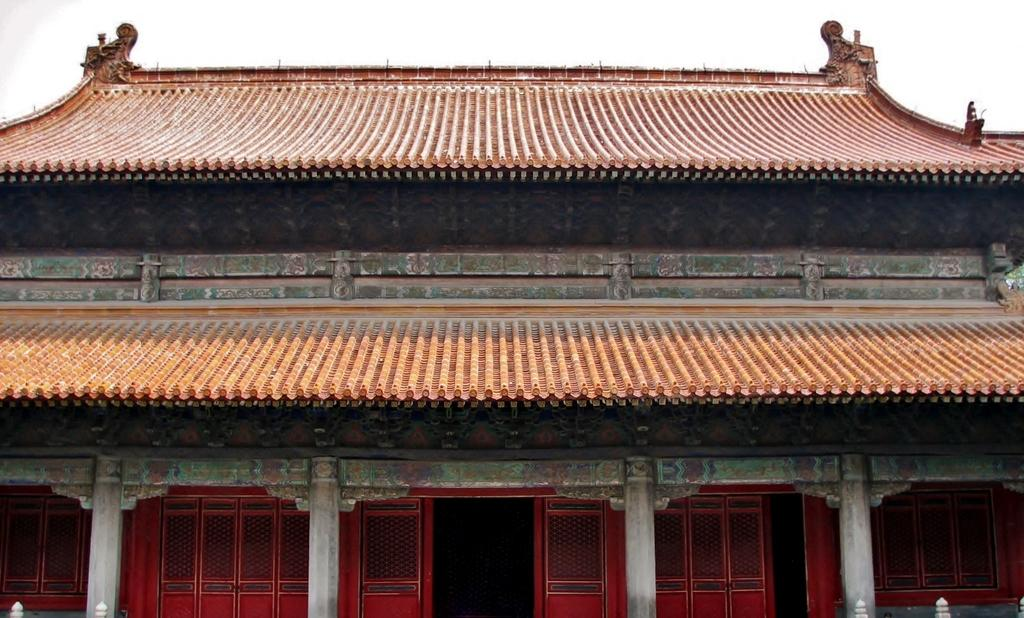What type of house is in the foreground of the image? There is a Chinese house in the foreground of the image. Can you describe the entrance to the Chinese house? There is an entrance to the Chinese house visible in the image. What can be seen in the background of the image? The sky is visible in the background of the image. How many sticks are being used by the father in the image? There is no father or sticks present in the image. 